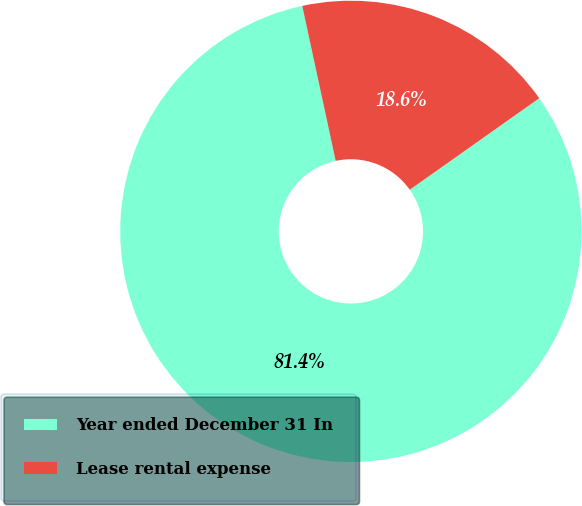Convert chart to OTSL. <chart><loc_0><loc_0><loc_500><loc_500><pie_chart><fcel>Year ended December 31 In<fcel>Lease rental expense<nl><fcel>81.41%<fcel>18.59%<nl></chart> 